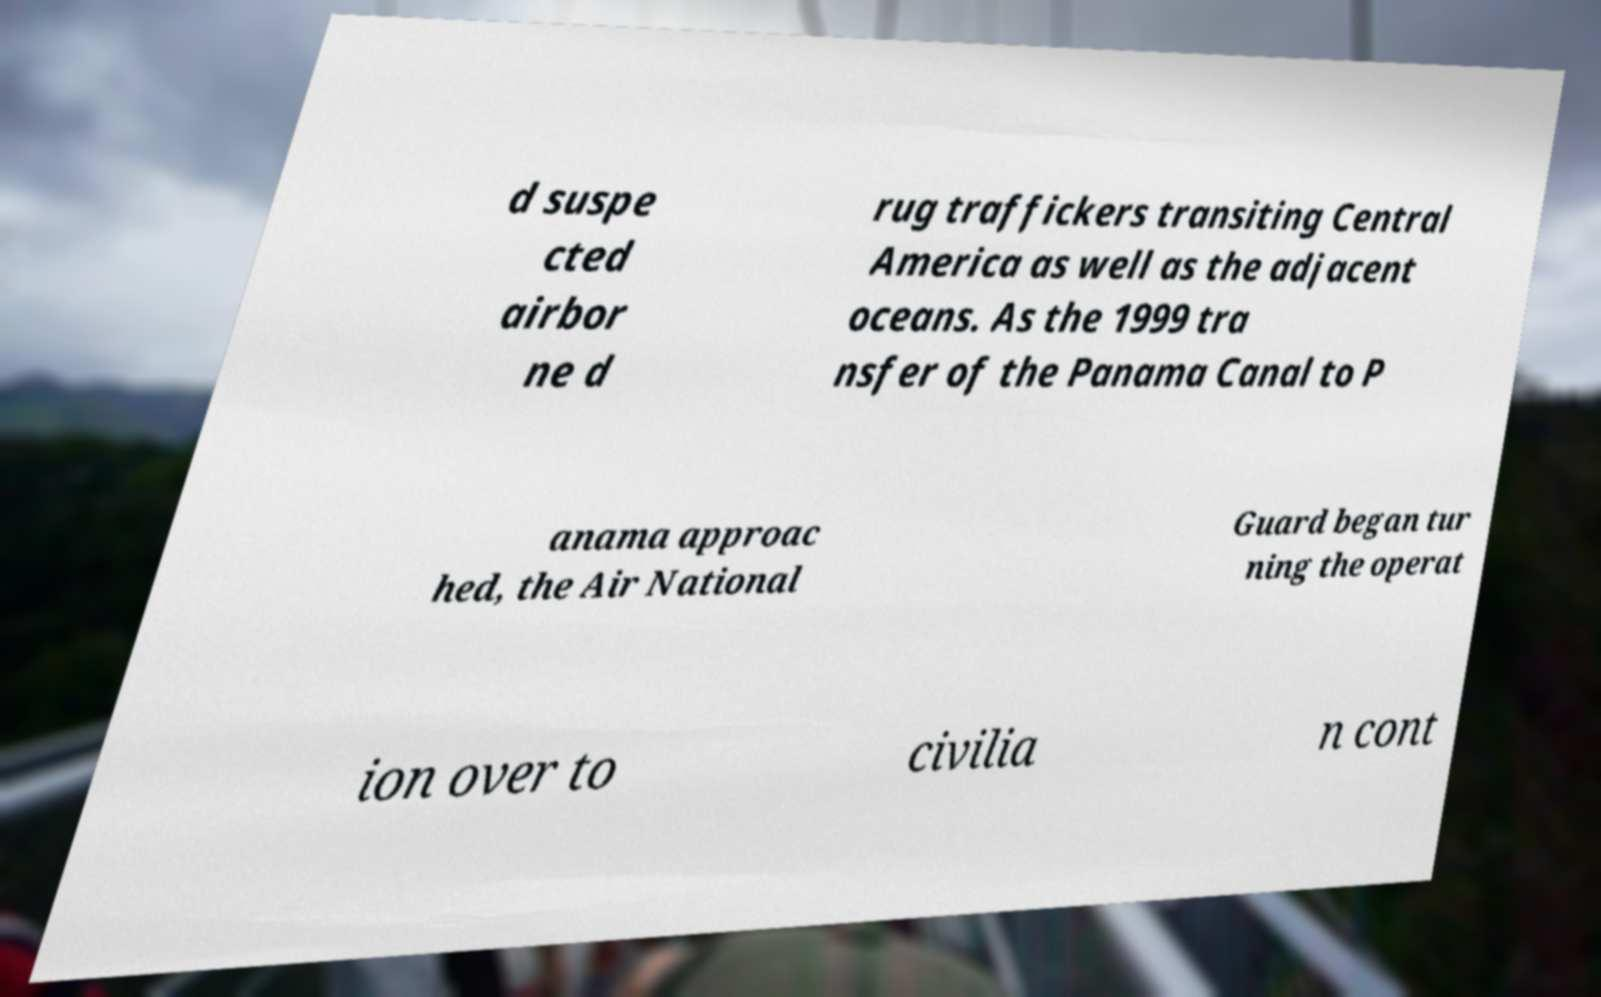Could you assist in decoding the text presented in this image and type it out clearly? d suspe cted airbor ne d rug traffickers transiting Central America as well as the adjacent oceans. As the 1999 tra nsfer of the Panama Canal to P anama approac hed, the Air National Guard began tur ning the operat ion over to civilia n cont 